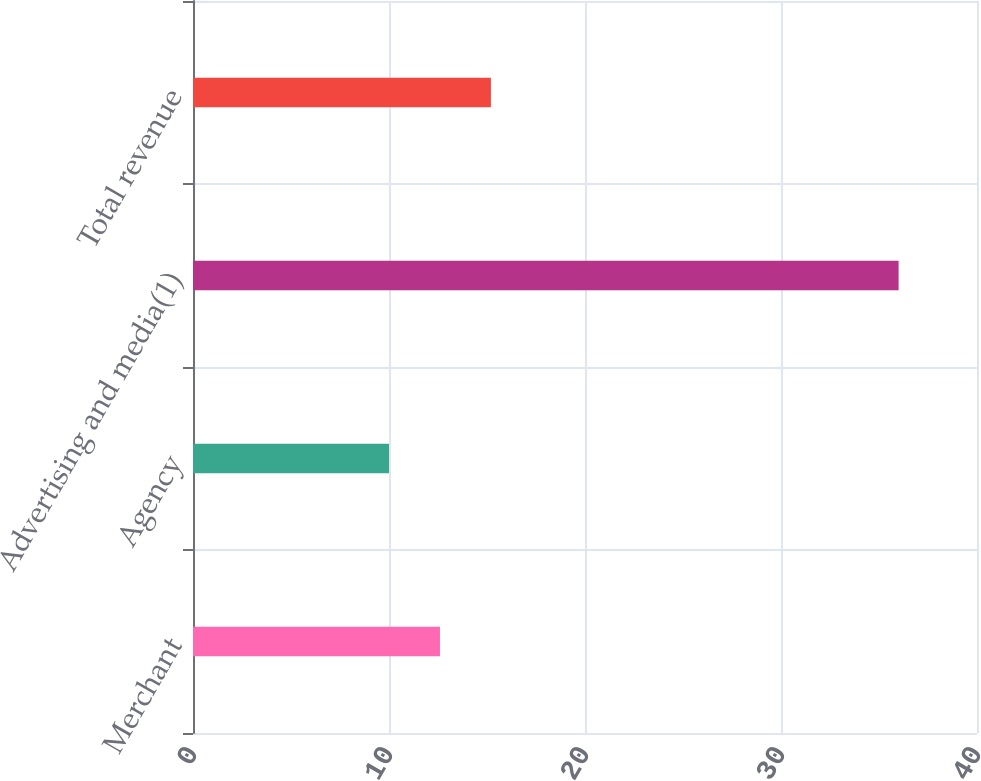<chart> <loc_0><loc_0><loc_500><loc_500><bar_chart><fcel>Merchant<fcel>Agency<fcel>Advertising and media(1)<fcel>Total revenue<nl><fcel>12.6<fcel>10<fcel>36<fcel>15.2<nl></chart> 